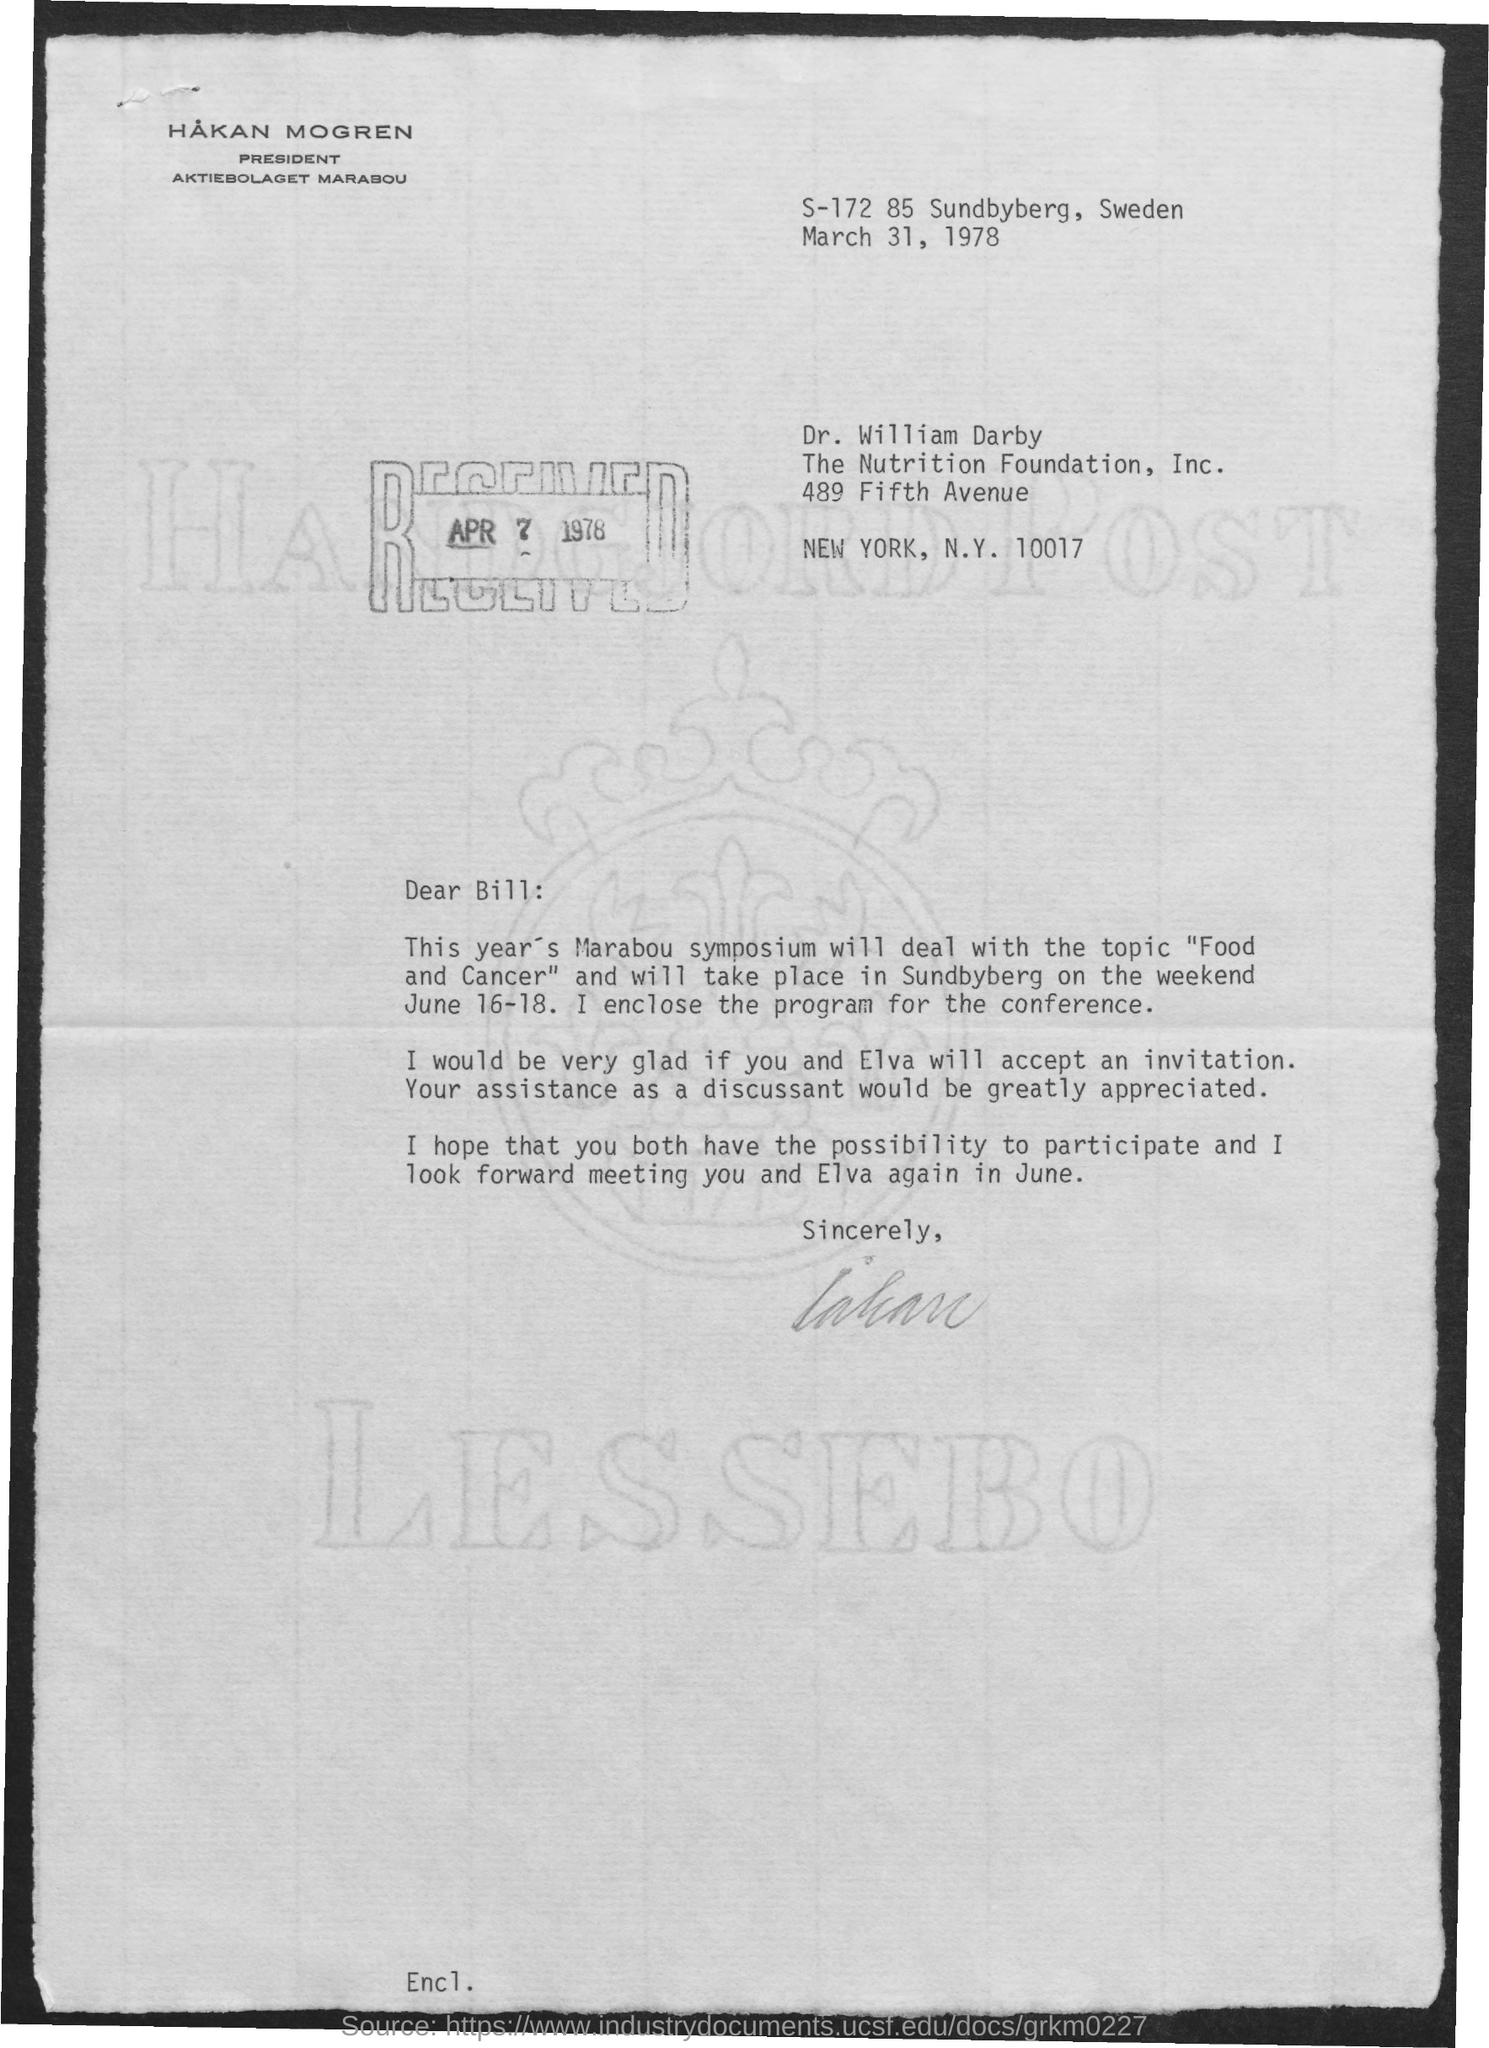Identify some key points in this picture. The topic of the symposium this year is Food and Cancer. 